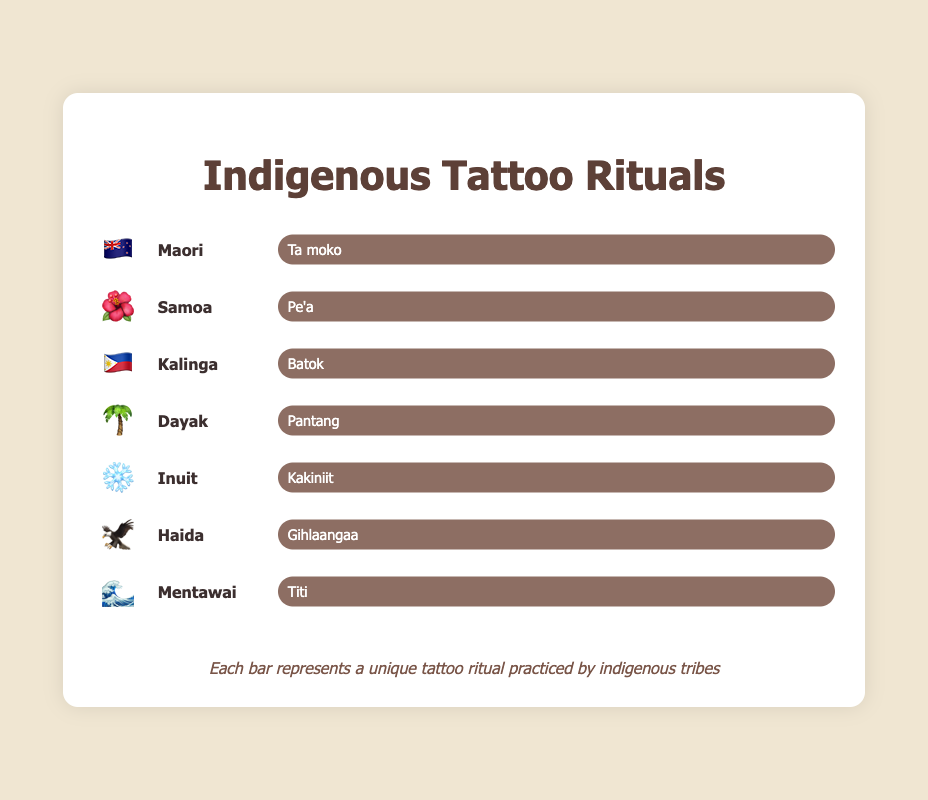What's the name of the tattoo ritual for the Maori tribe? Look at the Maori tribe entry. The ritual name is displayed next to the emoji 🇳🇿.
Answer: Ta moko Which tribe uses the ritual named 'Pe'a'? Locate the ritual 'Pe'a' in the figure. The emoji 🌺 is associated with the Samoa tribe.
Answer: Samoa Identify the emojis used for the Inuit and Haida tribes. Look for the entries for the Inuit and Haida tribes. The Inuit tribe uses ❄️, and the Haida tribe uses 🦅.
Answer: ❄️, 🦅 Compare the tattoo rituals 'Batok' and 'Kakiniit'. Which tribes practice them? Find 'Batok' and 'Kakiniit' in the figure and identify the associated tribes. 'Batok' is practiced by Kalinga 🇵🇭, and 'Kakiniit' is practiced by Inuit ❄️.
Answer: Kalinga, Inuit Count the number of tribes displayed in the figure. Count each tribe entry from top to bottom. There are seven tribes listed.
Answer: Seven What is the cultural symbol (emoji) for the Dayak tribe, and what is their tattoo ritual called? Check the entry for the Dayak tribe. The emoji used is 🌴, and the ritual is called Pantang.
Answer: 🌴, Pantang Are there more tribes with animal-related or nature-related emojis in the figure? Compare the emojis: two are animal-related (🦅 for Haida, 🦅 for another) and three are nature-related (🌺, 🌴, ❄️). There are more nature-related emojis.
Answer: Nature-related List the names of all tattoo rituals shown in the figure. Identify and list each ritual name: Ta moko, Pe'a, Batok, Pantang, Kakiniit, Gihlaangaa, Titi.
Answer: Ta moko, Pe'a, Batok, Pantang, Kakiniit, Gihlaangaa, Titi What ritual does the Mentawai tribe practice, and how is it visually represented in the figure? Check the Mentawai entry. The ritual is Titi, and it is represented with the emoji 🌊.
Answer: Titi, 🌊 